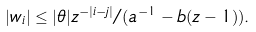Convert formula to latex. <formula><loc_0><loc_0><loc_500><loc_500>| w _ { i } | \leq | \theta | z ^ { - | i - j | } / ( a ^ { - 1 } - b ( z - 1 ) ) .</formula> 